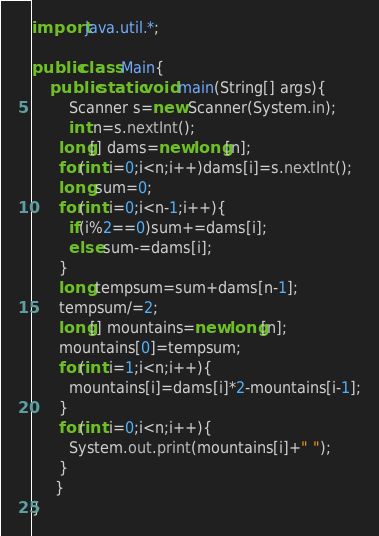Convert code to text. <code><loc_0><loc_0><loc_500><loc_500><_Java_>import java.util.*;

public class Main{
	public static void main(String[] args){
    	Scanner s=new Scanner(System.in);
      	int n=s.nextInt();
      long[] dams=new long[n];
      for(int i=0;i<n;i++)dams[i]=s.nextInt();
      long sum=0;
      for(int i=0;i<n-1;i++){
    	if(i%2==0)sum+=dams[i];
        else sum-=dams[i];
      }
      long tempsum=sum+dams[n-1];
      tempsum/=2;
      long[] mountains=new long[n];
      mountains[0]=tempsum;
      for(int i=1;i<n;i++){
      	mountains[i]=dams[i]*2-mountains[i-1];
      }
      for(int i=0;i<n;i++){
      	System.out.print(mountains[i]+" ");
      }
     }
}</code> 